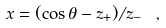<formula> <loc_0><loc_0><loc_500><loc_500>x = ( \cos \theta - z _ { + } ) / z _ { - } \ ,</formula> 